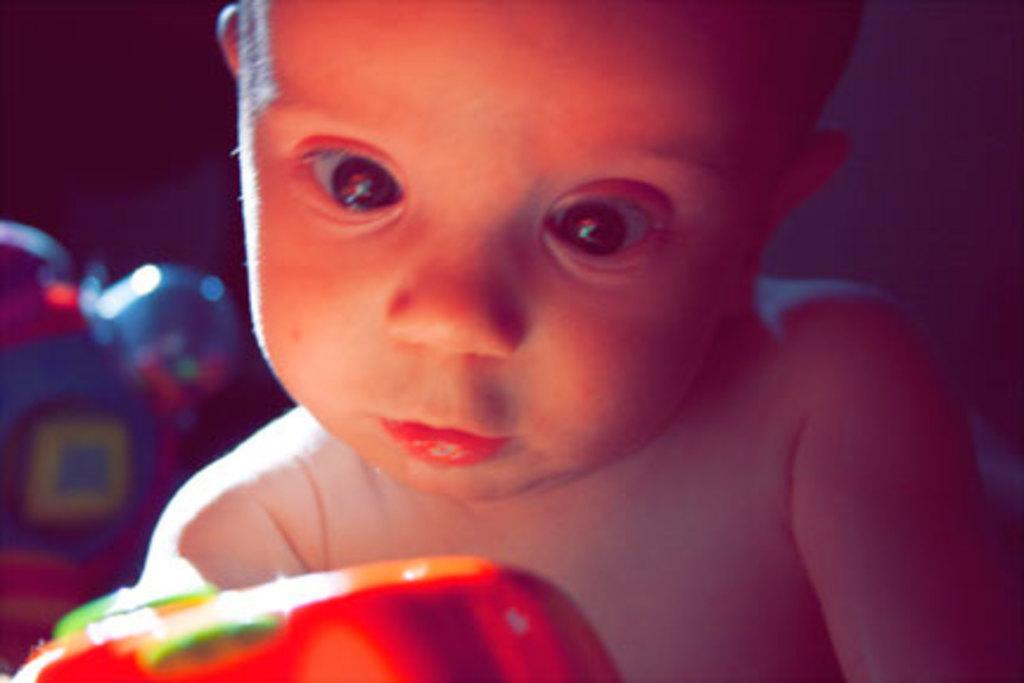How would you summarize this image in a sentence or two? In this image we can see a baby. In the background, we can see two toys. 